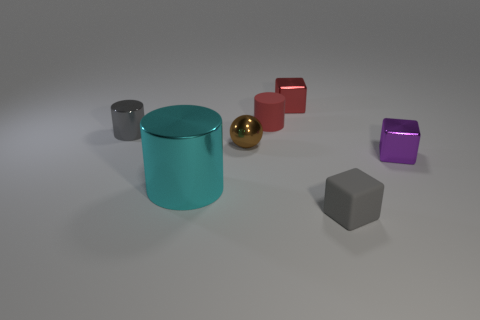Add 1 brown metal balls. How many objects exist? 8 Subtract all cylinders. How many objects are left? 4 Subtract 0 green cylinders. How many objects are left? 7 Subtract all big purple spheres. Subtract all tiny cylinders. How many objects are left? 5 Add 3 tiny red rubber things. How many tiny red rubber things are left? 4 Add 4 tiny brown balls. How many tiny brown balls exist? 5 